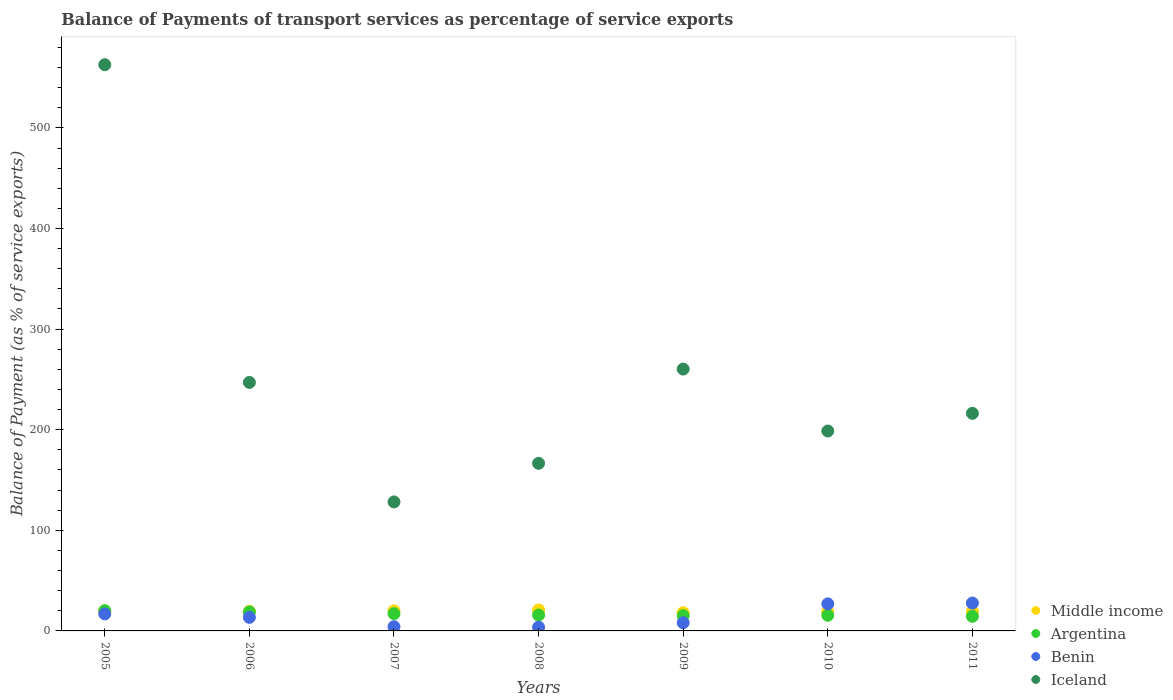Is the number of dotlines equal to the number of legend labels?
Offer a terse response. Yes. What is the balance of payments of transport services in Middle income in 2011?
Your answer should be very brief. 19.24. Across all years, what is the maximum balance of payments of transport services in Benin?
Provide a succinct answer. 27.71. Across all years, what is the minimum balance of payments of transport services in Iceland?
Give a very brief answer. 128.23. What is the total balance of payments of transport services in Iceland in the graph?
Provide a succinct answer. 1779.87. What is the difference between the balance of payments of transport services in Middle income in 2007 and that in 2009?
Your answer should be compact. 1.91. What is the difference between the balance of payments of transport services in Middle income in 2008 and the balance of payments of transport services in Benin in 2007?
Your answer should be very brief. 16.63. What is the average balance of payments of transport services in Middle income per year?
Make the answer very short. 19.41. In the year 2009, what is the difference between the balance of payments of transport services in Benin and balance of payments of transport services in Middle income?
Provide a succinct answer. -9.98. What is the ratio of the balance of payments of transport services in Iceland in 2008 to that in 2010?
Provide a short and direct response. 0.84. Is the balance of payments of transport services in Iceland in 2006 less than that in 2011?
Provide a short and direct response. No. What is the difference between the highest and the second highest balance of payments of transport services in Benin?
Your answer should be very brief. 0.83. What is the difference between the highest and the lowest balance of payments of transport services in Middle income?
Provide a short and direct response. 2.72. In how many years, is the balance of payments of transport services in Middle income greater than the average balance of payments of transport services in Middle income taken over all years?
Your response must be concise. 3. Is the sum of the balance of payments of transport services in Middle income in 2007 and 2010 greater than the maximum balance of payments of transport services in Argentina across all years?
Provide a succinct answer. Yes. Is it the case that in every year, the sum of the balance of payments of transport services in Iceland and balance of payments of transport services in Middle income  is greater than the sum of balance of payments of transport services in Argentina and balance of payments of transport services in Benin?
Your answer should be very brief. Yes. Does the balance of payments of transport services in Middle income monotonically increase over the years?
Your answer should be very brief. No. Is the balance of payments of transport services in Iceland strictly greater than the balance of payments of transport services in Benin over the years?
Keep it short and to the point. Yes. Is the balance of payments of transport services in Middle income strictly less than the balance of payments of transport services in Benin over the years?
Keep it short and to the point. No. How many years are there in the graph?
Offer a terse response. 7. Does the graph contain any zero values?
Make the answer very short. No. Does the graph contain grids?
Your response must be concise. No. Where does the legend appear in the graph?
Make the answer very short. Bottom right. How many legend labels are there?
Provide a succinct answer. 4. What is the title of the graph?
Provide a short and direct response. Balance of Payments of transport services as percentage of service exports. Does "Iceland" appear as one of the legend labels in the graph?
Provide a short and direct response. Yes. What is the label or title of the X-axis?
Provide a short and direct response. Years. What is the label or title of the Y-axis?
Keep it short and to the point. Balance of Payment (as % of service exports). What is the Balance of Payment (as % of service exports) of Middle income in 2005?
Offer a terse response. 19.25. What is the Balance of Payment (as % of service exports) in Argentina in 2005?
Provide a succinct answer. 20.2. What is the Balance of Payment (as % of service exports) in Benin in 2005?
Keep it short and to the point. 16.92. What is the Balance of Payment (as % of service exports) of Iceland in 2005?
Your answer should be compact. 562.81. What is the Balance of Payment (as % of service exports) in Middle income in 2006?
Make the answer very short. 19.48. What is the Balance of Payment (as % of service exports) of Argentina in 2006?
Offer a terse response. 18.84. What is the Balance of Payment (as % of service exports) of Benin in 2006?
Your answer should be very brief. 13.46. What is the Balance of Payment (as % of service exports) of Iceland in 2006?
Offer a very short reply. 247. What is the Balance of Payment (as % of service exports) of Middle income in 2007?
Give a very brief answer. 20. What is the Balance of Payment (as % of service exports) in Argentina in 2007?
Your answer should be compact. 17.19. What is the Balance of Payment (as % of service exports) in Benin in 2007?
Give a very brief answer. 4.18. What is the Balance of Payment (as % of service exports) in Iceland in 2007?
Provide a succinct answer. 128.23. What is the Balance of Payment (as % of service exports) in Middle income in 2008?
Ensure brevity in your answer.  20.82. What is the Balance of Payment (as % of service exports) in Argentina in 2008?
Offer a terse response. 15.78. What is the Balance of Payment (as % of service exports) in Benin in 2008?
Offer a very short reply. 3.73. What is the Balance of Payment (as % of service exports) of Iceland in 2008?
Your answer should be compact. 166.58. What is the Balance of Payment (as % of service exports) of Middle income in 2009?
Your answer should be compact. 18.1. What is the Balance of Payment (as % of service exports) of Argentina in 2009?
Make the answer very short. 15.2. What is the Balance of Payment (as % of service exports) of Benin in 2009?
Your response must be concise. 8.12. What is the Balance of Payment (as % of service exports) in Iceland in 2009?
Keep it short and to the point. 260.27. What is the Balance of Payment (as % of service exports) in Middle income in 2010?
Your answer should be very brief. 19.01. What is the Balance of Payment (as % of service exports) of Argentina in 2010?
Make the answer very short. 15.54. What is the Balance of Payment (as % of service exports) in Benin in 2010?
Offer a terse response. 26.88. What is the Balance of Payment (as % of service exports) in Iceland in 2010?
Offer a terse response. 198.71. What is the Balance of Payment (as % of service exports) in Middle income in 2011?
Offer a terse response. 19.24. What is the Balance of Payment (as % of service exports) of Argentina in 2011?
Provide a short and direct response. 14.51. What is the Balance of Payment (as % of service exports) in Benin in 2011?
Your answer should be compact. 27.71. What is the Balance of Payment (as % of service exports) in Iceland in 2011?
Keep it short and to the point. 216.28. Across all years, what is the maximum Balance of Payment (as % of service exports) in Middle income?
Make the answer very short. 20.82. Across all years, what is the maximum Balance of Payment (as % of service exports) of Argentina?
Provide a short and direct response. 20.2. Across all years, what is the maximum Balance of Payment (as % of service exports) of Benin?
Ensure brevity in your answer.  27.71. Across all years, what is the maximum Balance of Payment (as % of service exports) in Iceland?
Your response must be concise. 562.81. Across all years, what is the minimum Balance of Payment (as % of service exports) of Middle income?
Keep it short and to the point. 18.1. Across all years, what is the minimum Balance of Payment (as % of service exports) in Argentina?
Provide a succinct answer. 14.51. Across all years, what is the minimum Balance of Payment (as % of service exports) in Benin?
Your answer should be compact. 3.73. Across all years, what is the minimum Balance of Payment (as % of service exports) in Iceland?
Offer a very short reply. 128.23. What is the total Balance of Payment (as % of service exports) in Middle income in the graph?
Give a very brief answer. 135.89. What is the total Balance of Payment (as % of service exports) in Argentina in the graph?
Offer a very short reply. 117.27. What is the total Balance of Payment (as % of service exports) in Benin in the graph?
Your answer should be very brief. 101.01. What is the total Balance of Payment (as % of service exports) in Iceland in the graph?
Ensure brevity in your answer.  1779.87. What is the difference between the Balance of Payment (as % of service exports) of Middle income in 2005 and that in 2006?
Your answer should be compact. -0.23. What is the difference between the Balance of Payment (as % of service exports) in Argentina in 2005 and that in 2006?
Your answer should be very brief. 1.35. What is the difference between the Balance of Payment (as % of service exports) of Benin in 2005 and that in 2006?
Ensure brevity in your answer.  3.45. What is the difference between the Balance of Payment (as % of service exports) of Iceland in 2005 and that in 2006?
Provide a short and direct response. 315.81. What is the difference between the Balance of Payment (as % of service exports) of Middle income in 2005 and that in 2007?
Provide a succinct answer. -0.75. What is the difference between the Balance of Payment (as % of service exports) in Argentina in 2005 and that in 2007?
Make the answer very short. 3. What is the difference between the Balance of Payment (as % of service exports) in Benin in 2005 and that in 2007?
Provide a short and direct response. 12.73. What is the difference between the Balance of Payment (as % of service exports) of Iceland in 2005 and that in 2007?
Make the answer very short. 434.58. What is the difference between the Balance of Payment (as % of service exports) in Middle income in 2005 and that in 2008?
Offer a very short reply. -1.56. What is the difference between the Balance of Payment (as % of service exports) of Argentina in 2005 and that in 2008?
Your response must be concise. 4.42. What is the difference between the Balance of Payment (as % of service exports) in Benin in 2005 and that in 2008?
Your answer should be very brief. 13.18. What is the difference between the Balance of Payment (as % of service exports) of Iceland in 2005 and that in 2008?
Provide a short and direct response. 396.23. What is the difference between the Balance of Payment (as % of service exports) in Middle income in 2005 and that in 2009?
Offer a very short reply. 1.16. What is the difference between the Balance of Payment (as % of service exports) in Argentina in 2005 and that in 2009?
Provide a succinct answer. 5. What is the difference between the Balance of Payment (as % of service exports) in Benin in 2005 and that in 2009?
Make the answer very short. 8.8. What is the difference between the Balance of Payment (as % of service exports) in Iceland in 2005 and that in 2009?
Offer a terse response. 302.54. What is the difference between the Balance of Payment (as % of service exports) in Middle income in 2005 and that in 2010?
Offer a terse response. 0.25. What is the difference between the Balance of Payment (as % of service exports) in Argentina in 2005 and that in 2010?
Keep it short and to the point. 4.65. What is the difference between the Balance of Payment (as % of service exports) of Benin in 2005 and that in 2010?
Provide a succinct answer. -9.96. What is the difference between the Balance of Payment (as % of service exports) in Iceland in 2005 and that in 2010?
Offer a terse response. 364.1. What is the difference between the Balance of Payment (as % of service exports) of Middle income in 2005 and that in 2011?
Offer a very short reply. 0.02. What is the difference between the Balance of Payment (as % of service exports) in Argentina in 2005 and that in 2011?
Give a very brief answer. 5.68. What is the difference between the Balance of Payment (as % of service exports) in Benin in 2005 and that in 2011?
Your answer should be compact. -10.79. What is the difference between the Balance of Payment (as % of service exports) of Iceland in 2005 and that in 2011?
Your response must be concise. 346.53. What is the difference between the Balance of Payment (as % of service exports) of Middle income in 2006 and that in 2007?
Your answer should be very brief. -0.52. What is the difference between the Balance of Payment (as % of service exports) of Argentina in 2006 and that in 2007?
Offer a very short reply. 1.65. What is the difference between the Balance of Payment (as % of service exports) of Benin in 2006 and that in 2007?
Offer a very short reply. 9.28. What is the difference between the Balance of Payment (as % of service exports) of Iceland in 2006 and that in 2007?
Your answer should be very brief. 118.77. What is the difference between the Balance of Payment (as % of service exports) of Middle income in 2006 and that in 2008?
Offer a very short reply. -1.33. What is the difference between the Balance of Payment (as % of service exports) of Argentina in 2006 and that in 2008?
Make the answer very short. 3.07. What is the difference between the Balance of Payment (as % of service exports) of Benin in 2006 and that in 2008?
Ensure brevity in your answer.  9.73. What is the difference between the Balance of Payment (as % of service exports) of Iceland in 2006 and that in 2008?
Offer a terse response. 80.42. What is the difference between the Balance of Payment (as % of service exports) in Middle income in 2006 and that in 2009?
Offer a very short reply. 1.39. What is the difference between the Balance of Payment (as % of service exports) in Argentina in 2006 and that in 2009?
Make the answer very short. 3.64. What is the difference between the Balance of Payment (as % of service exports) of Benin in 2006 and that in 2009?
Make the answer very short. 5.35. What is the difference between the Balance of Payment (as % of service exports) in Iceland in 2006 and that in 2009?
Ensure brevity in your answer.  -13.27. What is the difference between the Balance of Payment (as % of service exports) of Middle income in 2006 and that in 2010?
Provide a short and direct response. 0.48. What is the difference between the Balance of Payment (as % of service exports) of Argentina in 2006 and that in 2010?
Make the answer very short. 3.3. What is the difference between the Balance of Payment (as % of service exports) in Benin in 2006 and that in 2010?
Offer a terse response. -13.42. What is the difference between the Balance of Payment (as % of service exports) in Iceland in 2006 and that in 2010?
Make the answer very short. 48.29. What is the difference between the Balance of Payment (as % of service exports) in Middle income in 2006 and that in 2011?
Ensure brevity in your answer.  0.24. What is the difference between the Balance of Payment (as % of service exports) of Argentina in 2006 and that in 2011?
Provide a short and direct response. 4.33. What is the difference between the Balance of Payment (as % of service exports) of Benin in 2006 and that in 2011?
Keep it short and to the point. -14.25. What is the difference between the Balance of Payment (as % of service exports) in Iceland in 2006 and that in 2011?
Your answer should be very brief. 30.72. What is the difference between the Balance of Payment (as % of service exports) of Middle income in 2007 and that in 2008?
Give a very brief answer. -0.82. What is the difference between the Balance of Payment (as % of service exports) in Argentina in 2007 and that in 2008?
Offer a very short reply. 1.42. What is the difference between the Balance of Payment (as % of service exports) in Benin in 2007 and that in 2008?
Ensure brevity in your answer.  0.45. What is the difference between the Balance of Payment (as % of service exports) in Iceland in 2007 and that in 2008?
Keep it short and to the point. -38.35. What is the difference between the Balance of Payment (as % of service exports) of Middle income in 2007 and that in 2009?
Keep it short and to the point. 1.91. What is the difference between the Balance of Payment (as % of service exports) of Argentina in 2007 and that in 2009?
Your response must be concise. 1.99. What is the difference between the Balance of Payment (as % of service exports) in Benin in 2007 and that in 2009?
Your response must be concise. -3.94. What is the difference between the Balance of Payment (as % of service exports) of Iceland in 2007 and that in 2009?
Provide a short and direct response. -132.04. What is the difference between the Balance of Payment (as % of service exports) of Argentina in 2007 and that in 2010?
Provide a short and direct response. 1.65. What is the difference between the Balance of Payment (as % of service exports) in Benin in 2007 and that in 2010?
Your response must be concise. -22.7. What is the difference between the Balance of Payment (as % of service exports) of Iceland in 2007 and that in 2010?
Offer a terse response. -70.48. What is the difference between the Balance of Payment (as % of service exports) of Middle income in 2007 and that in 2011?
Your answer should be very brief. 0.76. What is the difference between the Balance of Payment (as % of service exports) of Argentina in 2007 and that in 2011?
Offer a terse response. 2.68. What is the difference between the Balance of Payment (as % of service exports) of Benin in 2007 and that in 2011?
Your answer should be compact. -23.53. What is the difference between the Balance of Payment (as % of service exports) in Iceland in 2007 and that in 2011?
Keep it short and to the point. -88.05. What is the difference between the Balance of Payment (as % of service exports) of Middle income in 2008 and that in 2009?
Give a very brief answer. 2.72. What is the difference between the Balance of Payment (as % of service exports) of Argentina in 2008 and that in 2009?
Keep it short and to the point. 0.57. What is the difference between the Balance of Payment (as % of service exports) of Benin in 2008 and that in 2009?
Make the answer very short. -4.38. What is the difference between the Balance of Payment (as % of service exports) in Iceland in 2008 and that in 2009?
Your answer should be compact. -93.69. What is the difference between the Balance of Payment (as % of service exports) in Middle income in 2008 and that in 2010?
Your answer should be compact. 1.81. What is the difference between the Balance of Payment (as % of service exports) in Argentina in 2008 and that in 2010?
Keep it short and to the point. 0.23. What is the difference between the Balance of Payment (as % of service exports) in Benin in 2008 and that in 2010?
Make the answer very short. -23.15. What is the difference between the Balance of Payment (as % of service exports) in Iceland in 2008 and that in 2010?
Offer a terse response. -32.13. What is the difference between the Balance of Payment (as % of service exports) in Middle income in 2008 and that in 2011?
Offer a very short reply. 1.58. What is the difference between the Balance of Payment (as % of service exports) of Argentina in 2008 and that in 2011?
Provide a short and direct response. 1.26. What is the difference between the Balance of Payment (as % of service exports) of Benin in 2008 and that in 2011?
Provide a succinct answer. -23.97. What is the difference between the Balance of Payment (as % of service exports) in Iceland in 2008 and that in 2011?
Provide a short and direct response. -49.7. What is the difference between the Balance of Payment (as % of service exports) in Middle income in 2009 and that in 2010?
Make the answer very short. -0.91. What is the difference between the Balance of Payment (as % of service exports) of Argentina in 2009 and that in 2010?
Provide a succinct answer. -0.34. What is the difference between the Balance of Payment (as % of service exports) in Benin in 2009 and that in 2010?
Give a very brief answer. -18.76. What is the difference between the Balance of Payment (as % of service exports) in Iceland in 2009 and that in 2010?
Make the answer very short. 61.56. What is the difference between the Balance of Payment (as % of service exports) of Middle income in 2009 and that in 2011?
Keep it short and to the point. -1.14. What is the difference between the Balance of Payment (as % of service exports) of Argentina in 2009 and that in 2011?
Your answer should be very brief. 0.69. What is the difference between the Balance of Payment (as % of service exports) of Benin in 2009 and that in 2011?
Provide a short and direct response. -19.59. What is the difference between the Balance of Payment (as % of service exports) in Iceland in 2009 and that in 2011?
Your answer should be compact. 43.99. What is the difference between the Balance of Payment (as % of service exports) of Middle income in 2010 and that in 2011?
Make the answer very short. -0.23. What is the difference between the Balance of Payment (as % of service exports) of Argentina in 2010 and that in 2011?
Make the answer very short. 1.03. What is the difference between the Balance of Payment (as % of service exports) of Benin in 2010 and that in 2011?
Give a very brief answer. -0.83. What is the difference between the Balance of Payment (as % of service exports) of Iceland in 2010 and that in 2011?
Make the answer very short. -17.57. What is the difference between the Balance of Payment (as % of service exports) in Middle income in 2005 and the Balance of Payment (as % of service exports) in Argentina in 2006?
Your answer should be very brief. 0.41. What is the difference between the Balance of Payment (as % of service exports) in Middle income in 2005 and the Balance of Payment (as % of service exports) in Benin in 2006?
Your answer should be very brief. 5.79. What is the difference between the Balance of Payment (as % of service exports) in Middle income in 2005 and the Balance of Payment (as % of service exports) in Iceland in 2006?
Provide a succinct answer. -227.74. What is the difference between the Balance of Payment (as % of service exports) of Argentina in 2005 and the Balance of Payment (as % of service exports) of Benin in 2006?
Provide a succinct answer. 6.73. What is the difference between the Balance of Payment (as % of service exports) in Argentina in 2005 and the Balance of Payment (as % of service exports) in Iceland in 2006?
Your answer should be very brief. -226.8. What is the difference between the Balance of Payment (as % of service exports) of Benin in 2005 and the Balance of Payment (as % of service exports) of Iceland in 2006?
Provide a succinct answer. -230.08. What is the difference between the Balance of Payment (as % of service exports) in Middle income in 2005 and the Balance of Payment (as % of service exports) in Argentina in 2007?
Offer a very short reply. 2.06. What is the difference between the Balance of Payment (as % of service exports) of Middle income in 2005 and the Balance of Payment (as % of service exports) of Benin in 2007?
Offer a terse response. 15.07. What is the difference between the Balance of Payment (as % of service exports) in Middle income in 2005 and the Balance of Payment (as % of service exports) in Iceland in 2007?
Ensure brevity in your answer.  -108.97. What is the difference between the Balance of Payment (as % of service exports) of Argentina in 2005 and the Balance of Payment (as % of service exports) of Benin in 2007?
Your answer should be very brief. 16.02. What is the difference between the Balance of Payment (as % of service exports) of Argentina in 2005 and the Balance of Payment (as % of service exports) of Iceland in 2007?
Provide a succinct answer. -108.03. What is the difference between the Balance of Payment (as % of service exports) in Benin in 2005 and the Balance of Payment (as % of service exports) in Iceland in 2007?
Your answer should be very brief. -111.31. What is the difference between the Balance of Payment (as % of service exports) of Middle income in 2005 and the Balance of Payment (as % of service exports) of Argentina in 2008?
Offer a terse response. 3.48. What is the difference between the Balance of Payment (as % of service exports) of Middle income in 2005 and the Balance of Payment (as % of service exports) of Benin in 2008?
Ensure brevity in your answer.  15.52. What is the difference between the Balance of Payment (as % of service exports) in Middle income in 2005 and the Balance of Payment (as % of service exports) in Iceland in 2008?
Offer a very short reply. -147.33. What is the difference between the Balance of Payment (as % of service exports) in Argentina in 2005 and the Balance of Payment (as % of service exports) in Benin in 2008?
Keep it short and to the point. 16.46. What is the difference between the Balance of Payment (as % of service exports) of Argentina in 2005 and the Balance of Payment (as % of service exports) of Iceland in 2008?
Ensure brevity in your answer.  -146.38. What is the difference between the Balance of Payment (as % of service exports) of Benin in 2005 and the Balance of Payment (as % of service exports) of Iceland in 2008?
Your answer should be very brief. -149.67. What is the difference between the Balance of Payment (as % of service exports) in Middle income in 2005 and the Balance of Payment (as % of service exports) in Argentina in 2009?
Provide a short and direct response. 4.05. What is the difference between the Balance of Payment (as % of service exports) of Middle income in 2005 and the Balance of Payment (as % of service exports) of Benin in 2009?
Your answer should be very brief. 11.14. What is the difference between the Balance of Payment (as % of service exports) in Middle income in 2005 and the Balance of Payment (as % of service exports) in Iceland in 2009?
Provide a short and direct response. -241.01. What is the difference between the Balance of Payment (as % of service exports) of Argentina in 2005 and the Balance of Payment (as % of service exports) of Benin in 2009?
Offer a very short reply. 12.08. What is the difference between the Balance of Payment (as % of service exports) in Argentina in 2005 and the Balance of Payment (as % of service exports) in Iceland in 2009?
Provide a short and direct response. -240.07. What is the difference between the Balance of Payment (as % of service exports) of Benin in 2005 and the Balance of Payment (as % of service exports) of Iceland in 2009?
Your answer should be compact. -243.35. What is the difference between the Balance of Payment (as % of service exports) of Middle income in 2005 and the Balance of Payment (as % of service exports) of Argentina in 2010?
Your response must be concise. 3.71. What is the difference between the Balance of Payment (as % of service exports) of Middle income in 2005 and the Balance of Payment (as % of service exports) of Benin in 2010?
Offer a very short reply. -7.63. What is the difference between the Balance of Payment (as % of service exports) of Middle income in 2005 and the Balance of Payment (as % of service exports) of Iceland in 2010?
Give a very brief answer. -179.45. What is the difference between the Balance of Payment (as % of service exports) in Argentina in 2005 and the Balance of Payment (as % of service exports) in Benin in 2010?
Provide a short and direct response. -6.68. What is the difference between the Balance of Payment (as % of service exports) of Argentina in 2005 and the Balance of Payment (as % of service exports) of Iceland in 2010?
Offer a very short reply. -178.51. What is the difference between the Balance of Payment (as % of service exports) in Benin in 2005 and the Balance of Payment (as % of service exports) in Iceland in 2010?
Your answer should be very brief. -181.79. What is the difference between the Balance of Payment (as % of service exports) of Middle income in 2005 and the Balance of Payment (as % of service exports) of Argentina in 2011?
Offer a terse response. 4.74. What is the difference between the Balance of Payment (as % of service exports) of Middle income in 2005 and the Balance of Payment (as % of service exports) of Benin in 2011?
Your answer should be compact. -8.46. What is the difference between the Balance of Payment (as % of service exports) in Middle income in 2005 and the Balance of Payment (as % of service exports) in Iceland in 2011?
Provide a short and direct response. -197.03. What is the difference between the Balance of Payment (as % of service exports) in Argentina in 2005 and the Balance of Payment (as % of service exports) in Benin in 2011?
Your answer should be very brief. -7.51. What is the difference between the Balance of Payment (as % of service exports) in Argentina in 2005 and the Balance of Payment (as % of service exports) in Iceland in 2011?
Offer a very short reply. -196.08. What is the difference between the Balance of Payment (as % of service exports) of Benin in 2005 and the Balance of Payment (as % of service exports) of Iceland in 2011?
Your answer should be compact. -199.36. What is the difference between the Balance of Payment (as % of service exports) of Middle income in 2006 and the Balance of Payment (as % of service exports) of Argentina in 2007?
Provide a succinct answer. 2.29. What is the difference between the Balance of Payment (as % of service exports) of Middle income in 2006 and the Balance of Payment (as % of service exports) of Benin in 2007?
Keep it short and to the point. 15.3. What is the difference between the Balance of Payment (as % of service exports) of Middle income in 2006 and the Balance of Payment (as % of service exports) of Iceland in 2007?
Ensure brevity in your answer.  -108.75. What is the difference between the Balance of Payment (as % of service exports) in Argentina in 2006 and the Balance of Payment (as % of service exports) in Benin in 2007?
Ensure brevity in your answer.  14.66. What is the difference between the Balance of Payment (as % of service exports) in Argentina in 2006 and the Balance of Payment (as % of service exports) in Iceland in 2007?
Offer a terse response. -109.38. What is the difference between the Balance of Payment (as % of service exports) of Benin in 2006 and the Balance of Payment (as % of service exports) of Iceland in 2007?
Your answer should be compact. -114.76. What is the difference between the Balance of Payment (as % of service exports) of Middle income in 2006 and the Balance of Payment (as % of service exports) of Argentina in 2008?
Your answer should be very brief. 3.71. What is the difference between the Balance of Payment (as % of service exports) of Middle income in 2006 and the Balance of Payment (as % of service exports) of Benin in 2008?
Your answer should be compact. 15.75. What is the difference between the Balance of Payment (as % of service exports) of Middle income in 2006 and the Balance of Payment (as % of service exports) of Iceland in 2008?
Your answer should be compact. -147.1. What is the difference between the Balance of Payment (as % of service exports) in Argentina in 2006 and the Balance of Payment (as % of service exports) in Benin in 2008?
Your answer should be compact. 15.11. What is the difference between the Balance of Payment (as % of service exports) in Argentina in 2006 and the Balance of Payment (as % of service exports) in Iceland in 2008?
Ensure brevity in your answer.  -147.74. What is the difference between the Balance of Payment (as % of service exports) of Benin in 2006 and the Balance of Payment (as % of service exports) of Iceland in 2008?
Give a very brief answer. -153.12. What is the difference between the Balance of Payment (as % of service exports) in Middle income in 2006 and the Balance of Payment (as % of service exports) in Argentina in 2009?
Your response must be concise. 4.28. What is the difference between the Balance of Payment (as % of service exports) of Middle income in 2006 and the Balance of Payment (as % of service exports) of Benin in 2009?
Offer a terse response. 11.36. What is the difference between the Balance of Payment (as % of service exports) in Middle income in 2006 and the Balance of Payment (as % of service exports) in Iceland in 2009?
Ensure brevity in your answer.  -240.79. What is the difference between the Balance of Payment (as % of service exports) in Argentina in 2006 and the Balance of Payment (as % of service exports) in Benin in 2009?
Offer a very short reply. 10.73. What is the difference between the Balance of Payment (as % of service exports) in Argentina in 2006 and the Balance of Payment (as % of service exports) in Iceland in 2009?
Provide a succinct answer. -241.43. What is the difference between the Balance of Payment (as % of service exports) in Benin in 2006 and the Balance of Payment (as % of service exports) in Iceland in 2009?
Ensure brevity in your answer.  -246.8. What is the difference between the Balance of Payment (as % of service exports) of Middle income in 2006 and the Balance of Payment (as % of service exports) of Argentina in 2010?
Keep it short and to the point. 3.94. What is the difference between the Balance of Payment (as % of service exports) in Middle income in 2006 and the Balance of Payment (as % of service exports) in Benin in 2010?
Make the answer very short. -7.4. What is the difference between the Balance of Payment (as % of service exports) of Middle income in 2006 and the Balance of Payment (as % of service exports) of Iceland in 2010?
Make the answer very short. -179.23. What is the difference between the Balance of Payment (as % of service exports) in Argentina in 2006 and the Balance of Payment (as % of service exports) in Benin in 2010?
Your answer should be very brief. -8.04. What is the difference between the Balance of Payment (as % of service exports) in Argentina in 2006 and the Balance of Payment (as % of service exports) in Iceland in 2010?
Keep it short and to the point. -179.86. What is the difference between the Balance of Payment (as % of service exports) in Benin in 2006 and the Balance of Payment (as % of service exports) in Iceland in 2010?
Your answer should be compact. -185.24. What is the difference between the Balance of Payment (as % of service exports) of Middle income in 2006 and the Balance of Payment (as % of service exports) of Argentina in 2011?
Your answer should be very brief. 4.97. What is the difference between the Balance of Payment (as % of service exports) in Middle income in 2006 and the Balance of Payment (as % of service exports) in Benin in 2011?
Ensure brevity in your answer.  -8.23. What is the difference between the Balance of Payment (as % of service exports) of Middle income in 2006 and the Balance of Payment (as % of service exports) of Iceland in 2011?
Your answer should be compact. -196.8. What is the difference between the Balance of Payment (as % of service exports) in Argentina in 2006 and the Balance of Payment (as % of service exports) in Benin in 2011?
Provide a succinct answer. -8.87. What is the difference between the Balance of Payment (as % of service exports) in Argentina in 2006 and the Balance of Payment (as % of service exports) in Iceland in 2011?
Make the answer very short. -197.44. What is the difference between the Balance of Payment (as % of service exports) of Benin in 2006 and the Balance of Payment (as % of service exports) of Iceland in 2011?
Your answer should be very brief. -202.82. What is the difference between the Balance of Payment (as % of service exports) in Middle income in 2007 and the Balance of Payment (as % of service exports) in Argentina in 2008?
Give a very brief answer. 4.23. What is the difference between the Balance of Payment (as % of service exports) in Middle income in 2007 and the Balance of Payment (as % of service exports) in Benin in 2008?
Give a very brief answer. 16.27. What is the difference between the Balance of Payment (as % of service exports) in Middle income in 2007 and the Balance of Payment (as % of service exports) in Iceland in 2008?
Provide a succinct answer. -146.58. What is the difference between the Balance of Payment (as % of service exports) of Argentina in 2007 and the Balance of Payment (as % of service exports) of Benin in 2008?
Give a very brief answer. 13.46. What is the difference between the Balance of Payment (as % of service exports) in Argentina in 2007 and the Balance of Payment (as % of service exports) in Iceland in 2008?
Offer a very short reply. -149.39. What is the difference between the Balance of Payment (as % of service exports) of Benin in 2007 and the Balance of Payment (as % of service exports) of Iceland in 2008?
Provide a succinct answer. -162.4. What is the difference between the Balance of Payment (as % of service exports) in Middle income in 2007 and the Balance of Payment (as % of service exports) in Argentina in 2009?
Give a very brief answer. 4.8. What is the difference between the Balance of Payment (as % of service exports) in Middle income in 2007 and the Balance of Payment (as % of service exports) in Benin in 2009?
Offer a very short reply. 11.88. What is the difference between the Balance of Payment (as % of service exports) in Middle income in 2007 and the Balance of Payment (as % of service exports) in Iceland in 2009?
Keep it short and to the point. -240.27. What is the difference between the Balance of Payment (as % of service exports) in Argentina in 2007 and the Balance of Payment (as % of service exports) in Benin in 2009?
Ensure brevity in your answer.  9.08. What is the difference between the Balance of Payment (as % of service exports) in Argentina in 2007 and the Balance of Payment (as % of service exports) in Iceland in 2009?
Ensure brevity in your answer.  -243.07. What is the difference between the Balance of Payment (as % of service exports) of Benin in 2007 and the Balance of Payment (as % of service exports) of Iceland in 2009?
Your answer should be very brief. -256.09. What is the difference between the Balance of Payment (as % of service exports) in Middle income in 2007 and the Balance of Payment (as % of service exports) in Argentina in 2010?
Offer a very short reply. 4.46. What is the difference between the Balance of Payment (as % of service exports) of Middle income in 2007 and the Balance of Payment (as % of service exports) of Benin in 2010?
Make the answer very short. -6.88. What is the difference between the Balance of Payment (as % of service exports) in Middle income in 2007 and the Balance of Payment (as % of service exports) in Iceland in 2010?
Offer a very short reply. -178.71. What is the difference between the Balance of Payment (as % of service exports) of Argentina in 2007 and the Balance of Payment (as % of service exports) of Benin in 2010?
Provide a succinct answer. -9.69. What is the difference between the Balance of Payment (as % of service exports) in Argentina in 2007 and the Balance of Payment (as % of service exports) in Iceland in 2010?
Your response must be concise. -181.51. What is the difference between the Balance of Payment (as % of service exports) in Benin in 2007 and the Balance of Payment (as % of service exports) in Iceland in 2010?
Your response must be concise. -194.52. What is the difference between the Balance of Payment (as % of service exports) of Middle income in 2007 and the Balance of Payment (as % of service exports) of Argentina in 2011?
Offer a terse response. 5.49. What is the difference between the Balance of Payment (as % of service exports) in Middle income in 2007 and the Balance of Payment (as % of service exports) in Benin in 2011?
Your response must be concise. -7.71. What is the difference between the Balance of Payment (as % of service exports) in Middle income in 2007 and the Balance of Payment (as % of service exports) in Iceland in 2011?
Make the answer very short. -196.28. What is the difference between the Balance of Payment (as % of service exports) of Argentina in 2007 and the Balance of Payment (as % of service exports) of Benin in 2011?
Keep it short and to the point. -10.52. What is the difference between the Balance of Payment (as % of service exports) in Argentina in 2007 and the Balance of Payment (as % of service exports) in Iceland in 2011?
Provide a succinct answer. -199.09. What is the difference between the Balance of Payment (as % of service exports) in Benin in 2007 and the Balance of Payment (as % of service exports) in Iceland in 2011?
Make the answer very short. -212.1. What is the difference between the Balance of Payment (as % of service exports) in Middle income in 2008 and the Balance of Payment (as % of service exports) in Argentina in 2009?
Make the answer very short. 5.61. What is the difference between the Balance of Payment (as % of service exports) in Middle income in 2008 and the Balance of Payment (as % of service exports) in Benin in 2009?
Your answer should be compact. 12.7. What is the difference between the Balance of Payment (as % of service exports) of Middle income in 2008 and the Balance of Payment (as % of service exports) of Iceland in 2009?
Make the answer very short. -239.45. What is the difference between the Balance of Payment (as % of service exports) in Argentina in 2008 and the Balance of Payment (as % of service exports) in Benin in 2009?
Your response must be concise. 7.66. What is the difference between the Balance of Payment (as % of service exports) in Argentina in 2008 and the Balance of Payment (as % of service exports) in Iceland in 2009?
Your response must be concise. -244.49. What is the difference between the Balance of Payment (as % of service exports) of Benin in 2008 and the Balance of Payment (as % of service exports) of Iceland in 2009?
Make the answer very short. -256.53. What is the difference between the Balance of Payment (as % of service exports) of Middle income in 2008 and the Balance of Payment (as % of service exports) of Argentina in 2010?
Offer a terse response. 5.27. What is the difference between the Balance of Payment (as % of service exports) in Middle income in 2008 and the Balance of Payment (as % of service exports) in Benin in 2010?
Your answer should be compact. -6.06. What is the difference between the Balance of Payment (as % of service exports) of Middle income in 2008 and the Balance of Payment (as % of service exports) of Iceland in 2010?
Make the answer very short. -177.89. What is the difference between the Balance of Payment (as % of service exports) in Argentina in 2008 and the Balance of Payment (as % of service exports) in Benin in 2010?
Your response must be concise. -11.11. What is the difference between the Balance of Payment (as % of service exports) in Argentina in 2008 and the Balance of Payment (as % of service exports) in Iceland in 2010?
Provide a succinct answer. -182.93. What is the difference between the Balance of Payment (as % of service exports) in Benin in 2008 and the Balance of Payment (as % of service exports) in Iceland in 2010?
Your answer should be compact. -194.97. What is the difference between the Balance of Payment (as % of service exports) in Middle income in 2008 and the Balance of Payment (as % of service exports) in Argentina in 2011?
Keep it short and to the point. 6.3. What is the difference between the Balance of Payment (as % of service exports) in Middle income in 2008 and the Balance of Payment (as % of service exports) in Benin in 2011?
Provide a succinct answer. -6.89. What is the difference between the Balance of Payment (as % of service exports) in Middle income in 2008 and the Balance of Payment (as % of service exports) in Iceland in 2011?
Keep it short and to the point. -195.46. What is the difference between the Balance of Payment (as % of service exports) of Argentina in 2008 and the Balance of Payment (as % of service exports) of Benin in 2011?
Provide a succinct answer. -11.93. What is the difference between the Balance of Payment (as % of service exports) of Argentina in 2008 and the Balance of Payment (as % of service exports) of Iceland in 2011?
Offer a very short reply. -200.51. What is the difference between the Balance of Payment (as % of service exports) in Benin in 2008 and the Balance of Payment (as % of service exports) in Iceland in 2011?
Offer a very short reply. -212.55. What is the difference between the Balance of Payment (as % of service exports) of Middle income in 2009 and the Balance of Payment (as % of service exports) of Argentina in 2010?
Your answer should be very brief. 2.55. What is the difference between the Balance of Payment (as % of service exports) of Middle income in 2009 and the Balance of Payment (as % of service exports) of Benin in 2010?
Provide a short and direct response. -8.78. What is the difference between the Balance of Payment (as % of service exports) in Middle income in 2009 and the Balance of Payment (as % of service exports) in Iceland in 2010?
Offer a very short reply. -180.61. What is the difference between the Balance of Payment (as % of service exports) in Argentina in 2009 and the Balance of Payment (as % of service exports) in Benin in 2010?
Offer a terse response. -11.68. What is the difference between the Balance of Payment (as % of service exports) in Argentina in 2009 and the Balance of Payment (as % of service exports) in Iceland in 2010?
Your answer should be very brief. -183.51. What is the difference between the Balance of Payment (as % of service exports) of Benin in 2009 and the Balance of Payment (as % of service exports) of Iceland in 2010?
Your answer should be very brief. -190.59. What is the difference between the Balance of Payment (as % of service exports) in Middle income in 2009 and the Balance of Payment (as % of service exports) in Argentina in 2011?
Your answer should be compact. 3.58. What is the difference between the Balance of Payment (as % of service exports) in Middle income in 2009 and the Balance of Payment (as % of service exports) in Benin in 2011?
Provide a short and direct response. -9.61. What is the difference between the Balance of Payment (as % of service exports) in Middle income in 2009 and the Balance of Payment (as % of service exports) in Iceland in 2011?
Ensure brevity in your answer.  -198.19. What is the difference between the Balance of Payment (as % of service exports) in Argentina in 2009 and the Balance of Payment (as % of service exports) in Benin in 2011?
Ensure brevity in your answer.  -12.51. What is the difference between the Balance of Payment (as % of service exports) of Argentina in 2009 and the Balance of Payment (as % of service exports) of Iceland in 2011?
Give a very brief answer. -201.08. What is the difference between the Balance of Payment (as % of service exports) of Benin in 2009 and the Balance of Payment (as % of service exports) of Iceland in 2011?
Provide a short and direct response. -208.16. What is the difference between the Balance of Payment (as % of service exports) of Middle income in 2010 and the Balance of Payment (as % of service exports) of Argentina in 2011?
Your answer should be compact. 4.49. What is the difference between the Balance of Payment (as % of service exports) of Middle income in 2010 and the Balance of Payment (as % of service exports) of Benin in 2011?
Ensure brevity in your answer.  -8.7. What is the difference between the Balance of Payment (as % of service exports) of Middle income in 2010 and the Balance of Payment (as % of service exports) of Iceland in 2011?
Offer a terse response. -197.28. What is the difference between the Balance of Payment (as % of service exports) of Argentina in 2010 and the Balance of Payment (as % of service exports) of Benin in 2011?
Offer a terse response. -12.17. What is the difference between the Balance of Payment (as % of service exports) of Argentina in 2010 and the Balance of Payment (as % of service exports) of Iceland in 2011?
Your answer should be very brief. -200.74. What is the difference between the Balance of Payment (as % of service exports) of Benin in 2010 and the Balance of Payment (as % of service exports) of Iceland in 2011?
Keep it short and to the point. -189.4. What is the average Balance of Payment (as % of service exports) of Middle income per year?
Your answer should be compact. 19.41. What is the average Balance of Payment (as % of service exports) of Argentina per year?
Your answer should be compact. 16.75. What is the average Balance of Payment (as % of service exports) in Benin per year?
Ensure brevity in your answer.  14.43. What is the average Balance of Payment (as % of service exports) of Iceland per year?
Keep it short and to the point. 254.27. In the year 2005, what is the difference between the Balance of Payment (as % of service exports) of Middle income and Balance of Payment (as % of service exports) of Argentina?
Your response must be concise. -0.94. In the year 2005, what is the difference between the Balance of Payment (as % of service exports) of Middle income and Balance of Payment (as % of service exports) of Benin?
Your answer should be very brief. 2.34. In the year 2005, what is the difference between the Balance of Payment (as % of service exports) of Middle income and Balance of Payment (as % of service exports) of Iceland?
Your response must be concise. -543.55. In the year 2005, what is the difference between the Balance of Payment (as % of service exports) of Argentina and Balance of Payment (as % of service exports) of Benin?
Your answer should be very brief. 3.28. In the year 2005, what is the difference between the Balance of Payment (as % of service exports) in Argentina and Balance of Payment (as % of service exports) in Iceland?
Give a very brief answer. -542.61. In the year 2005, what is the difference between the Balance of Payment (as % of service exports) of Benin and Balance of Payment (as % of service exports) of Iceland?
Provide a short and direct response. -545.89. In the year 2006, what is the difference between the Balance of Payment (as % of service exports) in Middle income and Balance of Payment (as % of service exports) in Argentina?
Ensure brevity in your answer.  0.64. In the year 2006, what is the difference between the Balance of Payment (as % of service exports) of Middle income and Balance of Payment (as % of service exports) of Benin?
Keep it short and to the point. 6.02. In the year 2006, what is the difference between the Balance of Payment (as % of service exports) of Middle income and Balance of Payment (as % of service exports) of Iceland?
Provide a succinct answer. -227.52. In the year 2006, what is the difference between the Balance of Payment (as % of service exports) of Argentina and Balance of Payment (as % of service exports) of Benin?
Provide a succinct answer. 5.38. In the year 2006, what is the difference between the Balance of Payment (as % of service exports) in Argentina and Balance of Payment (as % of service exports) in Iceland?
Make the answer very short. -228.15. In the year 2006, what is the difference between the Balance of Payment (as % of service exports) of Benin and Balance of Payment (as % of service exports) of Iceland?
Keep it short and to the point. -233.53. In the year 2007, what is the difference between the Balance of Payment (as % of service exports) of Middle income and Balance of Payment (as % of service exports) of Argentina?
Ensure brevity in your answer.  2.81. In the year 2007, what is the difference between the Balance of Payment (as % of service exports) of Middle income and Balance of Payment (as % of service exports) of Benin?
Give a very brief answer. 15.82. In the year 2007, what is the difference between the Balance of Payment (as % of service exports) in Middle income and Balance of Payment (as % of service exports) in Iceland?
Offer a terse response. -108.23. In the year 2007, what is the difference between the Balance of Payment (as % of service exports) in Argentina and Balance of Payment (as % of service exports) in Benin?
Give a very brief answer. 13.01. In the year 2007, what is the difference between the Balance of Payment (as % of service exports) of Argentina and Balance of Payment (as % of service exports) of Iceland?
Offer a terse response. -111.03. In the year 2007, what is the difference between the Balance of Payment (as % of service exports) of Benin and Balance of Payment (as % of service exports) of Iceland?
Offer a terse response. -124.04. In the year 2008, what is the difference between the Balance of Payment (as % of service exports) in Middle income and Balance of Payment (as % of service exports) in Argentina?
Make the answer very short. 5.04. In the year 2008, what is the difference between the Balance of Payment (as % of service exports) of Middle income and Balance of Payment (as % of service exports) of Benin?
Your answer should be very brief. 17.08. In the year 2008, what is the difference between the Balance of Payment (as % of service exports) in Middle income and Balance of Payment (as % of service exports) in Iceland?
Give a very brief answer. -145.77. In the year 2008, what is the difference between the Balance of Payment (as % of service exports) of Argentina and Balance of Payment (as % of service exports) of Benin?
Ensure brevity in your answer.  12.04. In the year 2008, what is the difference between the Balance of Payment (as % of service exports) in Argentina and Balance of Payment (as % of service exports) in Iceland?
Make the answer very short. -150.81. In the year 2008, what is the difference between the Balance of Payment (as % of service exports) in Benin and Balance of Payment (as % of service exports) in Iceland?
Keep it short and to the point. -162.85. In the year 2009, what is the difference between the Balance of Payment (as % of service exports) in Middle income and Balance of Payment (as % of service exports) in Argentina?
Make the answer very short. 2.89. In the year 2009, what is the difference between the Balance of Payment (as % of service exports) in Middle income and Balance of Payment (as % of service exports) in Benin?
Provide a succinct answer. 9.98. In the year 2009, what is the difference between the Balance of Payment (as % of service exports) in Middle income and Balance of Payment (as % of service exports) in Iceland?
Offer a very short reply. -242.17. In the year 2009, what is the difference between the Balance of Payment (as % of service exports) in Argentina and Balance of Payment (as % of service exports) in Benin?
Your answer should be compact. 7.08. In the year 2009, what is the difference between the Balance of Payment (as % of service exports) of Argentina and Balance of Payment (as % of service exports) of Iceland?
Keep it short and to the point. -245.07. In the year 2009, what is the difference between the Balance of Payment (as % of service exports) in Benin and Balance of Payment (as % of service exports) in Iceland?
Offer a very short reply. -252.15. In the year 2010, what is the difference between the Balance of Payment (as % of service exports) of Middle income and Balance of Payment (as % of service exports) of Argentina?
Give a very brief answer. 3.46. In the year 2010, what is the difference between the Balance of Payment (as % of service exports) of Middle income and Balance of Payment (as % of service exports) of Benin?
Provide a succinct answer. -7.87. In the year 2010, what is the difference between the Balance of Payment (as % of service exports) of Middle income and Balance of Payment (as % of service exports) of Iceland?
Provide a short and direct response. -179.7. In the year 2010, what is the difference between the Balance of Payment (as % of service exports) of Argentina and Balance of Payment (as % of service exports) of Benin?
Keep it short and to the point. -11.34. In the year 2010, what is the difference between the Balance of Payment (as % of service exports) of Argentina and Balance of Payment (as % of service exports) of Iceland?
Offer a terse response. -183.16. In the year 2010, what is the difference between the Balance of Payment (as % of service exports) in Benin and Balance of Payment (as % of service exports) in Iceland?
Offer a very short reply. -171.83. In the year 2011, what is the difference between the Balance of Payment (as % of service exports) of Middle income and Balance of Payment (as % of service exports) of Argentina?
Your answer should be compact. 4.72. In the year 2011, what is the difference between the Balance of Payment (as % of service exports) of Middle income and Balance of Payment (as % of service exports) of Benin?
Make the answer very short. -8.47. In the year 2011, what is the difference between the Balance of Payment (as % of service exports) in Middle income and Balance of Payment (as % of service exports) in Iceland?
Your response must be concise. -197.04. In the year 2011, what is the difference between the Balance of Payment (as % of service exports) of Argentina and Balance of Payment (as % of service exports) of Benin?
Provide a succinct answer. -13.2. In the year 2011, what is the difference between the Balance of Payment (as % of service exports) of Argentina and Balance of Payment (as % of service exports) of Iceland?
Provide a succinct answer. -201.77. In the year 2011, what is the difference between the Balance of Payment (as % of service exports) in Benin and Balance of Payment (as % of service exports) in Iceland?
Your answer should be very brief. -188.57. What is the ratio of the Balance of Payment (as % of service exports) in Middle income in 2005 to that in 2006?
Ensure brevity in your answer.  0.99. What is the ratio of the Balance of Payment (as % of service exports) in Argentina in 2005 to that in 2006?
Offer a terse response. 1.07. What is the ratio of the Balance of Payment (as % of service exports) of Benin in 2005 to that in 2006?
Make the answer very short. 1.26. What is the ratio of the Balance of Payment (as % of service exports) of Iceland in 2005 to that in 2006?
Give a very brief answer. 2.28. What is the ratio of the Balance of Payment (as % of service exports) in Middle income in 2005 to that in 2007?
Your answer should be compact. 0.96. What is the ratio of the Balance of Payment (as % of service exports) of Argentina in 2005 to that in 2007?
Your answer should be compact. 1.17. What is the ratio of the Balance of Payment (as % of service exports) in Benin in 2005 to that in 2007?
Provide a succinct answer. 4.04. What is the ratio of the Balance of Payment (as % of service exports) of Iceland in 2005 to that in 2007?
Your response must be concise. 4.39. What is the ratio of the Balance of Payment (as % of service exports) in Middle income in 2005 to that in 2008?
Keep it short and to the point. 0.93. What is the ratio of the Balance of Payment (as % of service exports) in Argentina in 2005 to that in 2008?
Offer a terse response. 1.28. What is the ratio of the Balance of Payment (as % of service exports) of Benin in 2005 to that in 2008?
Make the answer very short. 4.53. What is the ratio of the Balance of Payment (as % of service exports) in Iceland in 2005 to that in 2008?
Give a very brief answer. 3.38. What is the ratio of the Balance of Payment (as % of service exports) in Middle income in 2005 to that in 2009?
Offer a very short reply. 1.06. What is the ratio of the Balance of Payment (as % of service exports) of Argentina in 2005 to that in 2009?
Keep it short and to the point. 1.33. What is the ratio of the Balance of Payment (as % of service exports) of Benin in 2005 to that in 2009?
Your response must be concise. 2.08. What is the ratio of the Balance of Payment (as % of service exports) in Iceland in 2005 to that in 2009?
Offer a very short reply. 2.16. What is the ratio of the Balance of Payment (as % of service exports) of Middle income in 2005 to that in 2010?
Your answer should be very brief. 1.01. What is the ratio of the Balance of Payment (as % of service exports) of Argentina in 2005 to that in 2010?
Make the answer very short. 1.3. What is the ratio of the Balance of Payment (as % of service exports) of Benin in 2005 to that in 2010?
Give a very brief answer. 0.63. What is the ratio of the Balance of Payment (as % of service exports) of Iceland in 2005 to that in 2010?
Provide a short and direct response. 2.83. What is the ratio of the Balance of Payment (as % of service exports) in Argentina in 2005 to that in 2011?
Provide a short and direct response. 1.39. What is the ratio of the Balance of Payment (as % of service exports) in Benin in 2005 to that in 2011?
Provide a succinct answer. 0.61. What is the ratio of the Balance of Payment (as % of service exports) of Iceland in 2005 to that in 2011?
Give a very brief answer. 2.6. What is the ratio of the Balance of Payment (as % of service exports) in Middle income in 2006 to that in 2007?
Your answer should be very brief. 0.97. What is the ratio of the Balance of Payment (as % of service exports) of Argentina in 2006 to that in 2007?
Ensure brevity in your answer.  1.1. What is the ratio of the Balance of Payment (as % of service exports) in Benin in 2006 to that in 2007?
Provide a short and direct response. 3.22. What is the ratio of the Balance of Payment (as % of service exports) of Iceland in 2006 to that in 2007?
Keep it short and to the point. 1.93. What is the ratio of the Balance of Payment (as % of service exports) of Middle income in 2006 to that in 2008?
Provide a succinct answer. 0.94. What is the ratio of the Balance of Payment (as % of service exports) in Argentina in 2006 to that in 2008?
Give a very brief answer. 1.19. What is the ratio of the Balance of Payment (as % of service exports) of Benin in 2006 to that in 2008?
Give a very brief answer. 3.6. What is the ratio of the Balance of Payment (as % of service exports) in Iceland in 2006 to that in 2008?
Your answer should be compact. 1.48. What is the ratio of the Balance of Payment (as % of service exports) in Middle income in 2006 to that in 2009?
Give a very brief answer. 1.08. What is the ratio of the Balance of Payment (as % of service exports) in Argentina in 2006 to that in 2009?
Make the answer very short. 1.24. What is the ratio of the Balance of Payment (as % of service exports) of Benin in 2006 to that in 2009?
Your answer should be compact. 1.66. What is the ratio of the Balance of Payment (as % of service exports) in Iceland in 2006 to that in 2009?
Ensure brevity in your answer.  0.95. What is the ratio of the Balance of Payment (as % of service exports) of Middle income in 2006 to that in 2010?
Provide a succinct answer. 1.02. What is the ratio of the Balance of Payment (as % of service exports) of Argentina in 2006 to that in 2010?
Make the answer very short. 1.21. What is the ratio of the Balance of Payment (as % of service exports) of Benin in 2006 to that in 2010?
Make the answer very short. 0.5. What is the ratio of the Balance of Payment (as % of service exports) of Iceland in 2006 to that in 2010?
Provide a short and direct response. 1.24. What is the ratio of the Balance of Payment (as % of service exports) in Middle income in 2006 to that in 2011?
Offer a very short reply. 1.01. What is the ratio of the Balance of Payment (as % of service exports) of Argentina in 2006 to that in 2011?
Your response must be concise. 1.3. What is the ratio of the Balance of Payment (as % of service exports) of Benin in 2006 to that in 2011?
Make the answer very short. 0.49. What is the ratio of the Balance of Payment (as % of service exports) in Iceland in 2006 to that in 2011?
Your answer should be compact. 1.14. What is the ratio of the Balance of Payment (as % of service exports) in Middle income in 2007 to that in 2008?
Offer a very short reply. 0.96. What is the ratio of the Balance of Payment (as % of service exports) in Argentina in 2007 to that in 2008?
Ensure brevity in your answer.  1.09. What is the ratio of the Balance of Payment (as % of service exports) in Benin in 2007 to that in 2008?
Offer a terse response. 1.12. What is the ratio of the Balance of Payment (as % of service exports) of Iceland in 2007 to that in 2008?
Give a very brief answer. 0.77. What is the ratio of the Balance of Payment (as % of service exports) of Middle income in 2007 to that in 2009?
Make the answer very short. 1.11. What is the ratio of the Balance of Payment (as % of service exports) of Argentina in 2007 to that in 2009?
Ensure brevity in your answer.  1.13. What is the ratio of the Balance of Payment (as % of service exports) in Benin in 2007 to that in 2009?
Give a very brief answer. 0.52. What is the ratio of the Balance of Payment (as % of service exports) of Iceland in 2007 to that in 2009?
Provide a short and direct response. 0.49. What is the ratio of the Balance of Payment (as % of service exports) in Middle income in 2007 to that in 2010?
Your answer should be very brief. 1.05. What is the ratio of the Balance of Payment (as % of service exports) of Argentina in 2007 to that in 2010?
Keep it short and to the point. 1.11. What is the ratio of the Balance of Payment (as % of service exports) of Benin in 2007 to that in 2010?
Your answer should be very brief. 0.16. What is the ratio of the Balance of Payment (as % of service exports) of Iceland in 2007 to that in 2010?
Provide a short and direct response. 0.65. What is the ratio of the Balance of Payment (as % of service exports) in Middle income in 2007 to that in 2011?
Your response must be concise. 1.04. What is the ratio of the Balance of Payment (as % of service exports) in Argentina in 2007 to that in 2011?
Your answer should be compact. 1.18. What is the ratio of the Balance of Payment (as % of service exports) of Benin in 2007 to that in 2011?
Provide a short and direct response. 0.15. What is the ratio of the Balance of Payment (as % of service exports) in Iceland in 2007 to that in 2011?
Offer a very short reply. 0.59. What is the ratio of the Balance of Payment (as % of service exports) in Middle income in 2008 to that in 2009?
Give a very brief answer. 1.15. What is the ratio of the Balance of Payment (as % of service exports) in Argentina in 2008 to that in 2009?
Give a very brief answer. 1.04. What is the ratio of the Balance of Payment (as % of service exports) in Benin in 2008 to that in 2009?
Provide a succinct answer. 0.46. What is the ratio of the Balance of Payment (as % of service exports) in Iceland in 2008 to that in 2009?
Your answer should be compact. 0.64. What is the ratio of the Balance of Payment (as % of service exports) in Middle income in 2008 to that in 2010?
Keep it short and to the point. 1.1. What is the ratio of the Balance of Payment (as % of service exports) of Argentina in 2008 to that in 2010?
Offer a terse response. 1.01. What is the ratio of the Balance of Payment (as % of service exports) of Benin in 2008 to that in 2010?
Your answer should be compact. 0.14. What is the ratio of the Balance of Payment (as % of service exports) of Iceland in 2008 to that in 2010?
Keep it short and to the point. 0.84. What is the ratio of the Balance of Payment (as % of service exports) of Middle income in 2008 to that in 2011?
Your answer should be very brief. 1.08. What is the ratio of the Balance of Payment (as % of service exports) in Argentina in 2008 to that in 2011?
Your answer should be very brief. 1.09. What is the ratio of the Balance of Payment (as % of service exports) of Benin in 2008 to that in 2011?
Offer a terse response. 0.13. What is the ratio of the Balance of Payment (as % of service exports) of Iceland in 2008 to that in 2011?
Make the answer very short. 0.77. What is the ratio of the Balance of Payment (as % of service exports) of Middle income in 2009 to that in 2010?
Provide a succinct answer. 0.95. What is the ratio of the Balance of Payment (as % of service exports) of Argentina in 2009 to that in 2010?
Provide a short and direct response. 0.98. What is the ratio of the Balance of Payment (as % of service exports) of Benin in 2009 to that in 2010?
Your answer should be compact. 0.3. What is the ratio of the Balance of Payment (as % of service exports) of Iceland in 2009 to that in 2010?
Offer a very short reply. 1.31. What is the ratio of the Balance of Payment (as % of service exports) of Middle income in 2009 to that in 2011?
Provide a succinct answer. 0.94. What is the ratio of the Balance of Payment (as % of service exports) in Argentina in 2009 to that in 2011?
Offer a very short reply. 1.05. What is the ratio of the Balance of Payment (as % of service exports) of Benin in 2009 to that in 2011?
Provide a succinct answer. 0.29. What is the ratio of the Balance of Payment (as % of service exports) of Iceland in 2009 to that in 2011?
Keep it short and to the point. 1.2. What is the ratio of the Balance of Payment (as % of service exports) in Middle income in 2010 to that in 2011?
Your answer should be very brief. 0.99. What is the ratio of the Balance of Payment (as % of service exports) of Argentina in 2010 to that in 2011?
Make the answer very short. 1.07. What is the ratio of the Balance of Payment (as % of service exports) of Benin in 2010 to that in 2011?
Provide a short and direct response. 0.97. What is the ratio of the Balance of Payment (as % of service exports) of Iceland in 2010 to that in 2011?
Your answer should be very brief. 0.92. What is the difference between the highest and the second highest Balance of Payment (as % of service exports) of Middle income?
Your answer should be very brief. 0.82. What is the difference between the highest and the second highest Balance of Payment (as % of service exports) in Argentina?
Your response must be concise. 1.35. What is the difference between the highest and the second highest Balance of Payment (as % of service exports) of Benin?
Offer a very short reply. 0.83. What is the difference between the highest and the second highest Balance of Payment (as % of service exports) in Iceland?
Offer a terse response. 302.54. What is the difference between the highest and the lowest Balance of Payment (as % of service exports) of Middle income?
Make the answer very short. 2.72. What is the difference between the highest and the lowest Balance of Payment (as % of service exports) of Argentina?
Ensure brevity in your answer.  5.68. What is the difference between the highest and the lowest Balance of Payment (as % of service exports) of Benin?
Keep it short and to the point. 23.97. What is the difference between the highest and the lowest Balance of Payment (as % of service exports) in Iceland?
Give a very brief answer. 434.58. 